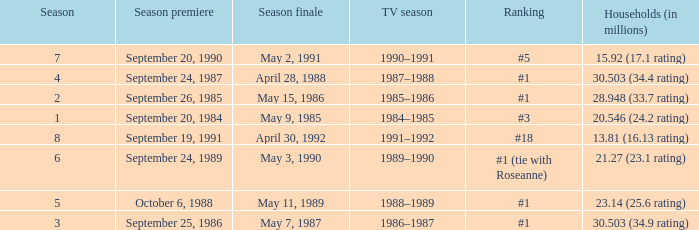Which TV season has a Season smaller than 8, and a Household (in millions) of 15.92 (17.1 rating)? 1990–1991. 